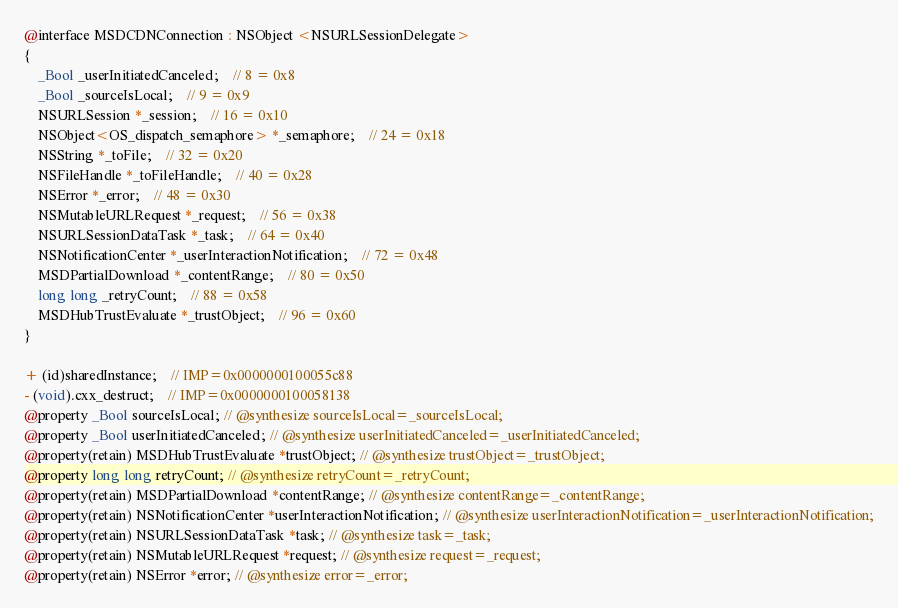Convert code to text. <code><loc_0><loc_0><loc_500><loc_500><_C_>@interface MSDCDNConnection : NSObject <NSURLSessionDelegate>
{
    _Bool _userInitiatedCanceled;	// 8 = 0x8
    _Bool _sourceIsLocal;	// 9 = 0x9
    NSURLSession *_session;	// 16 = 0x10
    NSObject<OS_dispatch_semaphore> *_semaphore;	// 24 = 0x18
    NSString *_toFile;	// 32 = 0x20
    NSFileHandle *_toFileHandle;	// 40 = 0x28
    NSError *_error;	// 48 = 0x30
    NSMutableURLRequest *_request;	// 56 = 0x38
    NSURLSessionDataTask *_task;	// 64 = 0x40
    NSNotificationCenter *_userInteractionNotification;	// 72 = 0x48
    MSDPartialDownload *_contentRange;	// 80 = 0x50
    long long _retryCount;	// 88 = 0x58
    MSDHubTrustEvaluate *_trustObject;	// 96 = 0x60
}

+ (id)sharedInstance;	// IMP=0x0000000100055c88
- (void).cxx_destruct;	// IMP=0x0000000100058138
@property _Bool sourceIsLocal; // @synthesize sourceIsLocal=_sourceIsLocal;
@property _Bool userInitiatedCanceled; // @synthesize userInitiatedCanceled=_userInitiatedCanceled;
@property(retain) MSDHubTrustEvaluate *trustObject; // @synthesize trustObject=_trustObject;
@property long long retryCount; // @synthesize retryCount=_retryCount;
@property(retain) MSDPartialDownload *contentRange; // @synthesize contentRange=_contentRange;
@property(retain) NSNotificationCenter *userInteractionNotification; // @synthesize userInteractionNotification=_userInteractionNotification;
@property(retain) NSURLSessionDataTask *task; // @synthesize task=_task;
@property(retain) NSMutableURLRequest *request; // @synthesize request=_request;
@property(retain) NSError *error; // @synthesize error=_error;</code> 